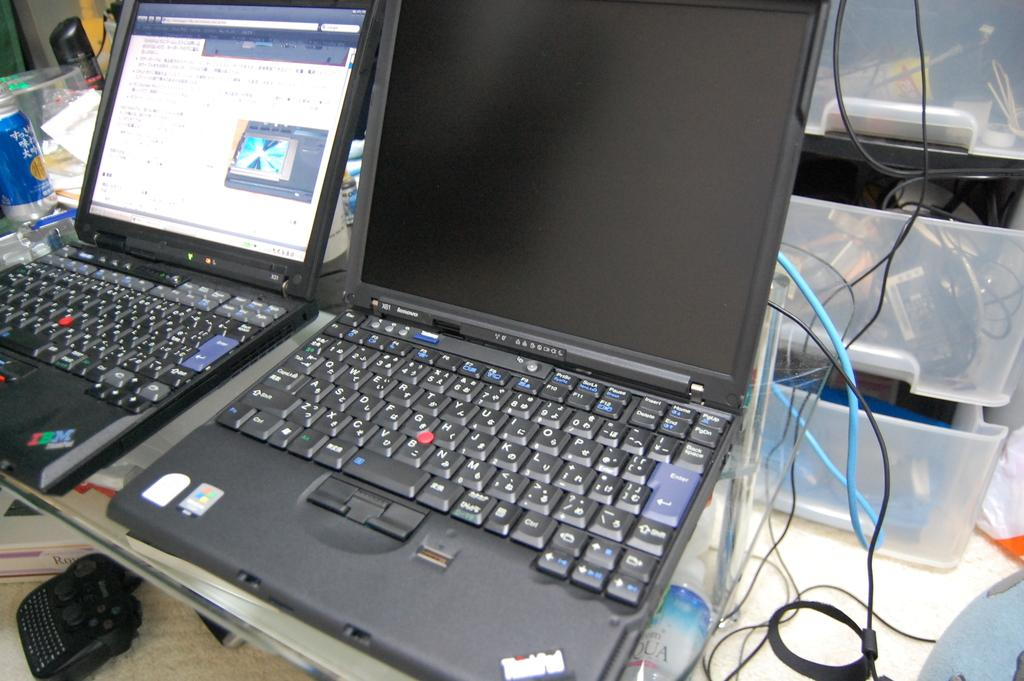<image>
Write a terse but informative summary of the picture. Two Lenovo laptops open next to each other 